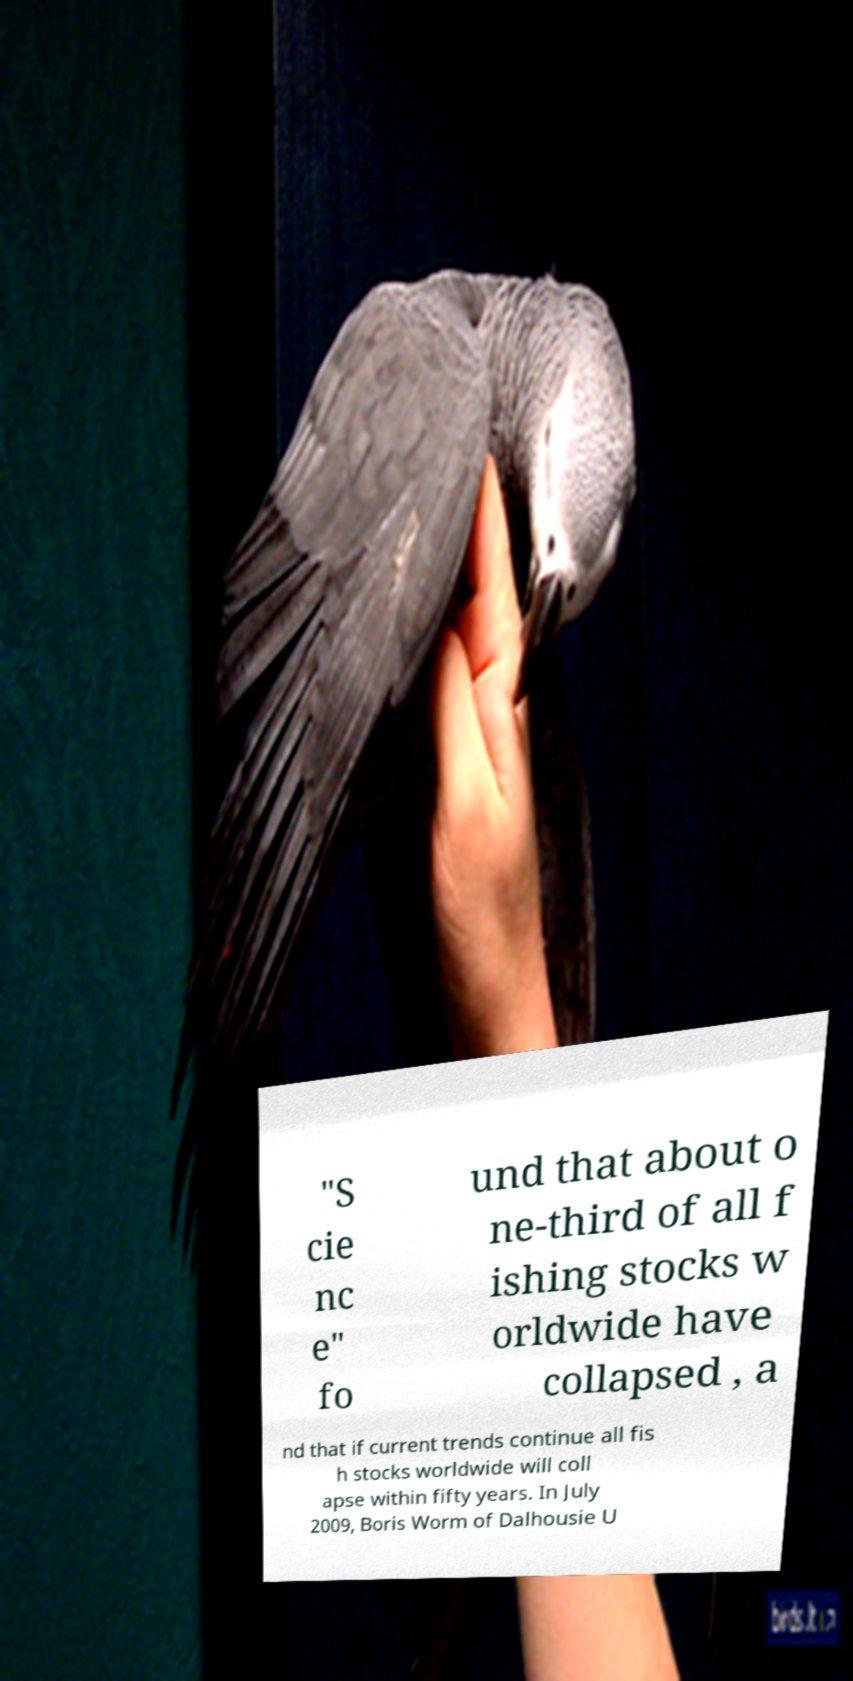What messages or text are displayed in this image? I need them in a readable, typed format. "S cie nc e" fo und that about o ne-third of all f ishing stocks w orldwide have collapsed , a nd that if current trends continue all fis h stocks worldwide will coll apse within fifty years. In July 2009, Boris Worm of Dalhousie U 